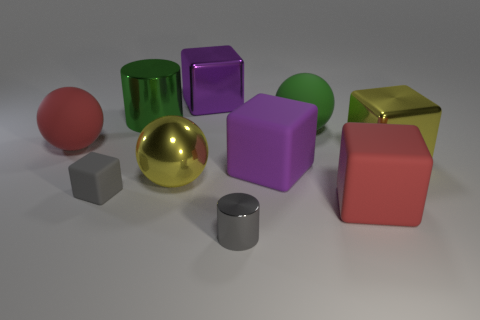What material is the other small object that is the same color as the small rubber thing?
Offer a terse response. Metal. There is a metallic object behind the green shiny object; is it the same size as the matte block on the left side of the tiny gray metallic cylinder?
Provide a succinct answer. No. Is the material of the large yellow sphere the same as the big purple thing that is in front of the large purple metal object?
Provide a short and direct response. No. Do the purple matte object and the big green rubber thing have the same shape?
Your answer should be very brief. No. How many other objects are the same material as the large green sphere?
Ensure brevity in your answer.  4. What number of tiny shiny things are the same shape as the large green metallic object?
Give a very brief answer. 1. What color is the large sphere that is both to the right of the small rubber object and behind the big yellow metal sphere?
Your answer should be very brief. Green. What number of blue rubber things are there?
Your answer should be very brief. 0. Does the yellow metal sphere have the same size as the gray cylinder?
Offer a very short reply. No. Are there any matte cubes that have the same color as the tiny shiny cylinder?
Ensure brevity in your answer.  Yes. 